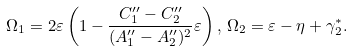Convert formula to latex. <formula><loc_0><loc_0><loc_500><loc_500>\Omega _ { 1 } = 2 \varepsilon \left ( 1 - \frac { C _ { 1 } ^ { \prime \prime } - C _ { 2 } ^ { \prime \prime } } { ( A _ { 1 } ^ { \prime \prime } - A _ { 2 } ^ { \prime \prime } ) ^ { 2 } } \varepsilon \right ) , \, \Omega _ { 2 } = \varepsilon - \eta + \gamma _ { 2 } ^ { * } .</formula> 